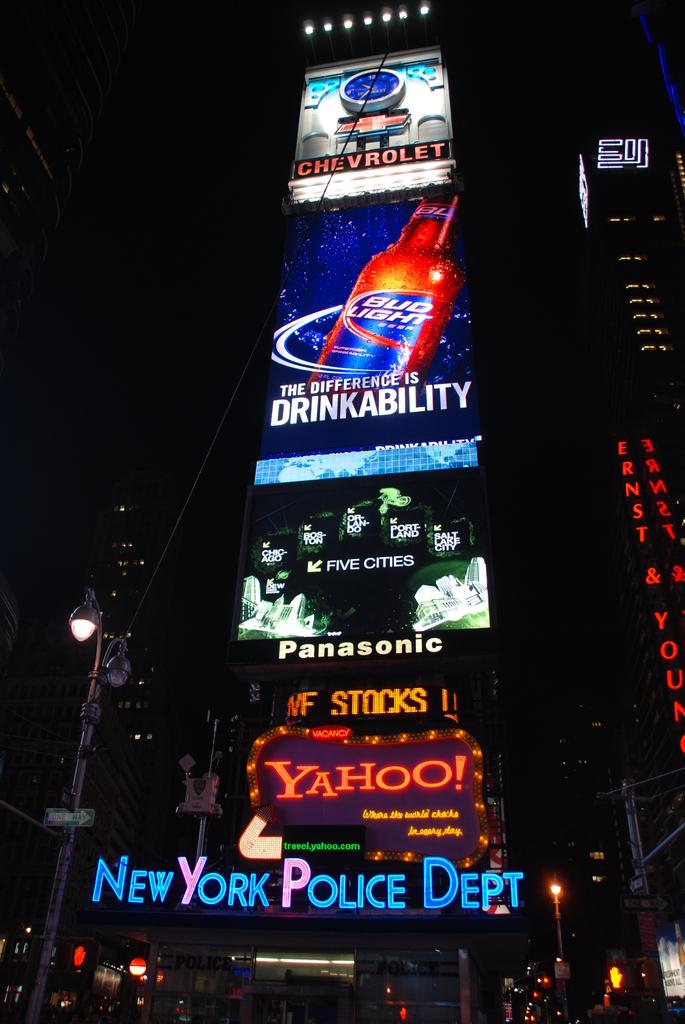What kind of police dept?
Offer a very short reply. New york. What car company is on the top advertisement?
Offer a very short reply. Chevrolet. 